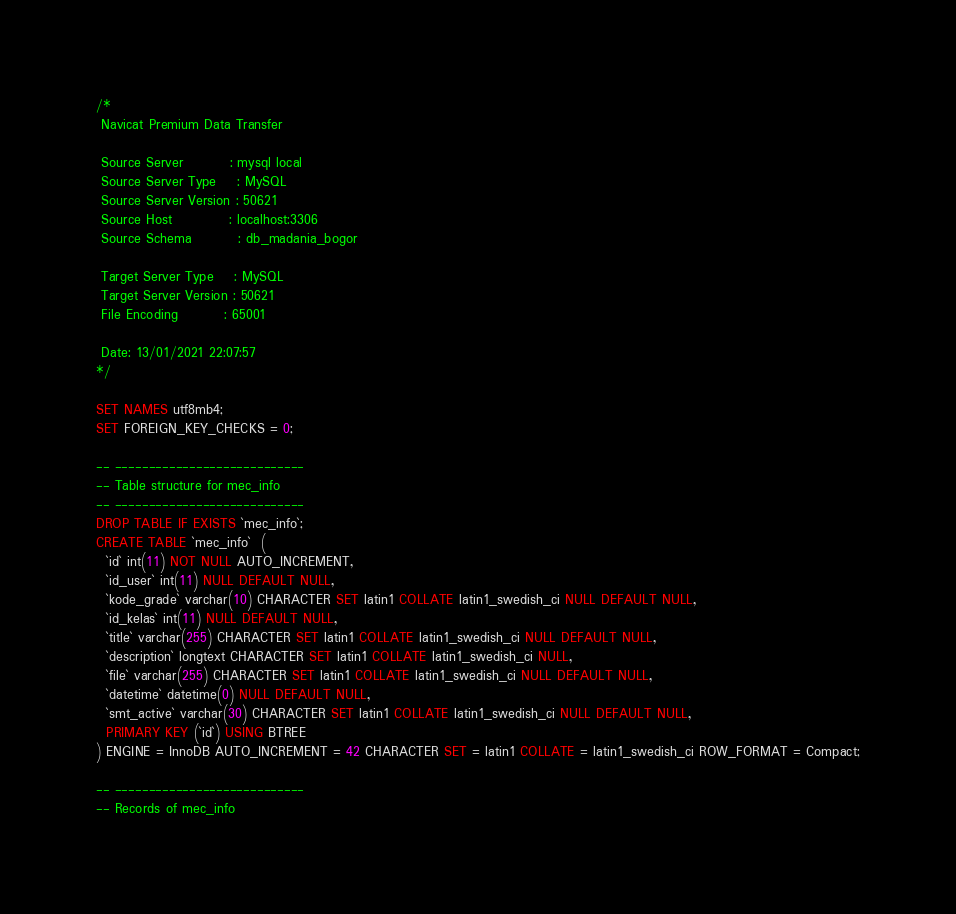<code> <loc_0><loc_0><loc_500><loc_500><_SQL_>/*
 Navicat Premium Data Transfer

 Source Server         : mysql local
 Source Server Type    : MySQL
 Source Server Version : 50621
 Source Host           : localhost:3306
 Source Schema         : db_madania_bogor

 Target Server Type    : MySQL
 Target Server Version : 50621
 File Encoding         : 65001

 Date: 13/01/2021 22:07:57
*/

SET NAMES utf8mb4;
SET FOREIGN_KEY_CHECKS = 0;

-- ----------------------------
-- Table structure for mec_info
-- ----------------------------
DROP TABLE IF EXISTS `mec_info`;
CREATE TABLE `mec_info`  (
  `id` int(11) NOT NULL AUTO_INCREMENT,
  `id_user` int(11) NULL DEFAULT NULL,
  `kode_grade` varchar(10) CHARACTER SET latin1 COLLATE latin1_swedish_ci NULL DEFAULT NULL,
  `id_kelas` int(11) NULL DEFAULT NULL,
  `title` varchar(255) CHARACTER SET latin1 COLLATE latin1_swedish_ci NULL DEFAULT NULL,
  `description` longtext CHARACTER SET latin1 COLLATE latin1_swedish_ci NULL,
  `file` varchar(255) CHARACTER SET latin1 COLLATE latin1_swedish_ci NULL DEFAULT NULL,
  `datetime` datetime(0) NULL DEFAULT NULL,
  `smt_active` varchar(30) CHARACTER SET latin1 COLLATE latin1_swedish_ci NULL DEFAULT NULL,
  PRIMARY KEY (`id`) USING BTREE
) ENGINE = InnoDB AUTO_INCREMENT = 42 CHARACTER SET = latin1 COLLATE = latin1_swedish_ci ROW_FORMAT = Compact;

-- ----------------------------
-- Records of mec_info</code> 